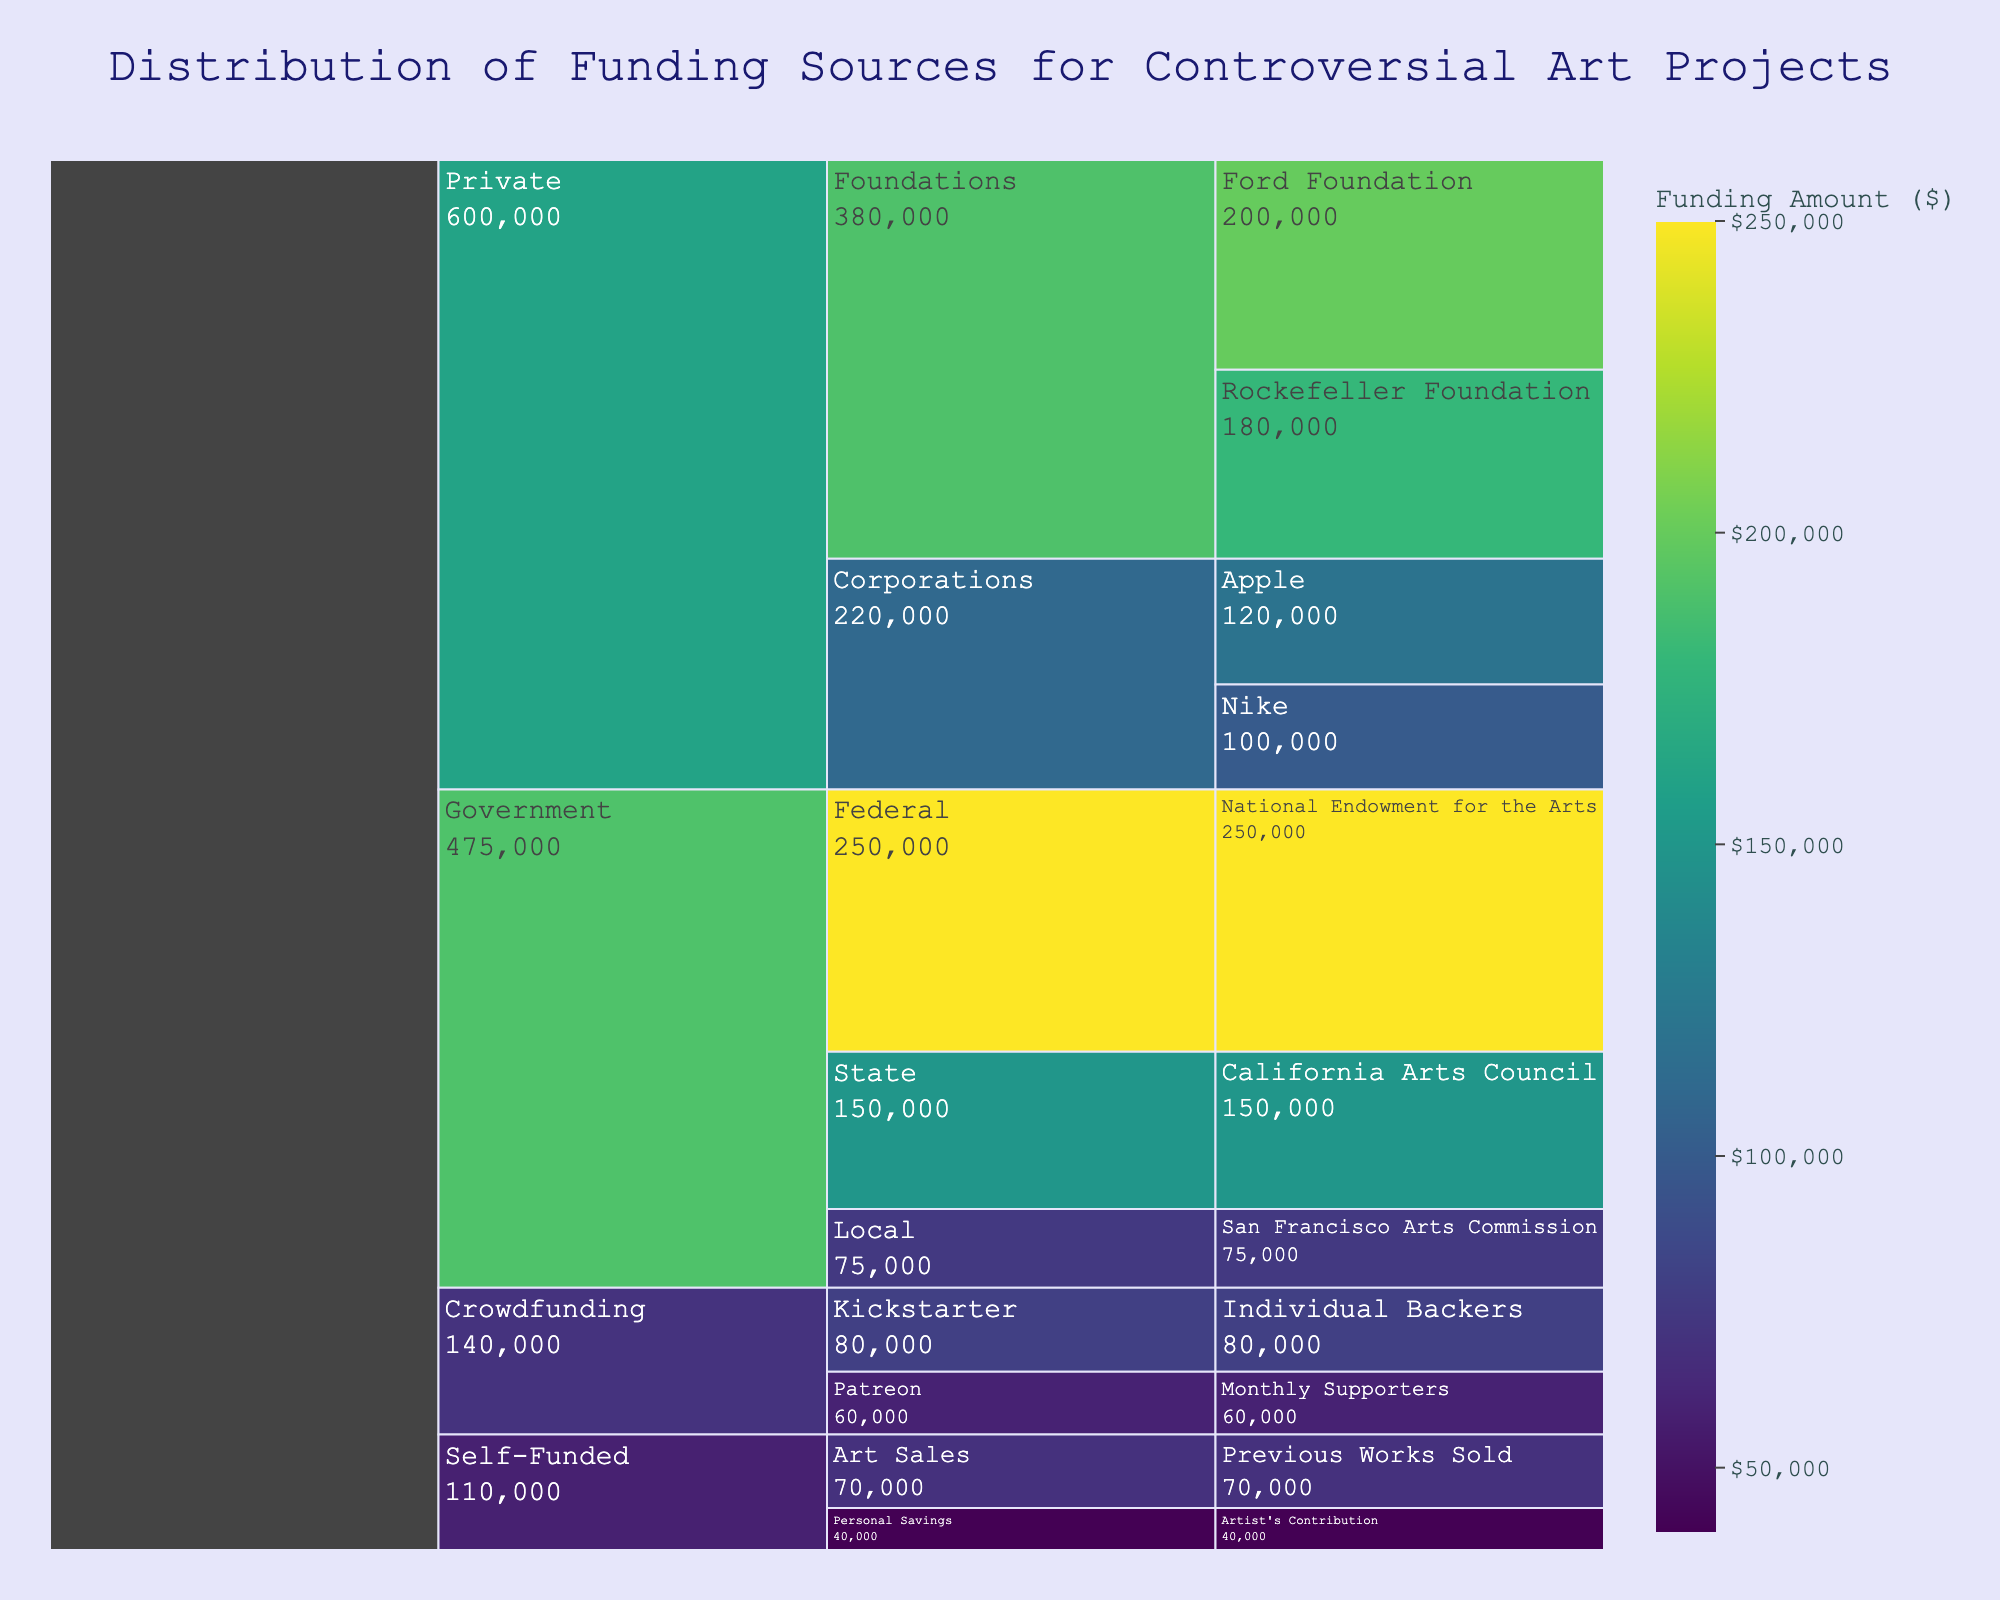Which category has the highest total funding amount? Look at the largest section in the icicle chart and check the associated label. The largest section is 'Government' when summed up across all its subcategories and funding sources, making it the highest.
Answer: Government What's the total funding amount for the 'Private' category? Sum up the amounts from all subcategories and funding sources under the 'Private' category: $200,000 (Ford Foundation) + $180,000 (Rockefeller Foundation) + $100,000 (Nike) + $120,000 (Apple) = $600,000.
Answer: $600,000 How does the funding from 'Crowdfunding' compare to 'Self-Funded'? Sum the amounts for both 'Crowdfunding' and 'Self-Funded': Crowdfunding: $80,000 (Kickstarter) + $60,000 (Patreon) = $140,000; Self-Funded: $40,000 (Personal Savings) + $70,000 (Art Sales) = $110,000. The amount from 'Crowdfunding' is higher.
Answer: Crowdfunding is higher Which has more funding: 'State' or 'Local' under 'Government'? Compare the funding amounts: State (California Arts Council) is $150,000 and Local (San Francisco Arts Commission) is $75,000.
Answer: State What's the combined funding amount from 'Nike' and 'Apple'? Add the amounts: Nike is $100,000 and Apple is $120,000. Thus, $100,000 + $120,000 = $220,000.
Answer: $220,000 Which subcategory within 'Government' has the least funding? Compare the amounts within 'Government' subcategories: Federal ($250,000), State ($150,000), and Local ($75,000). The least is Local.
Answer: Local How much more does 'National Endowment for the Arts' receive compared to the total from 'Self-Funded'? Compare: National Endowment for the Arts is $250,000 and the total for Self-Funded is $110,000 ($40,000 + $70,000). $250,000 - $110,000 = $140,000.
Answer: $140,000 What percentage of the total funding does the 'Ford Foundation' contribute? Calculate the total funding first: sum all amounts ($1,235,000). To find the percentage: ($200,000 / $1,235,000) * 100 ≈ 16.2%.
Answer: 16.2% What's the total funding amount for 'Crowdfunding' and 'Self-Funded' combined? Combine the totals from both categories: Crowdfunding ($80,000 + $60,000 = $140,000), Self-Funded ($40,000 + $70,000 = $110,000). Total: $140,000 + $110,000 = $250,000.
Answer: $250,000 Which funding source within 'Private' foundations has more funding: 'Ford Foundation' or 'Rockefeller Foundation'? Compare the amounts: Ford Foundation is $200,000, and Rockefeller Foundation is $180,000.
Answer: Ford Foundation 